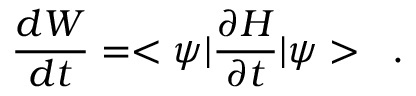<formula> <loc_0><loc_0><loc_500><loc_500>\frac { d W } { d t } = < \psi | \frac { \partial H } { \partial t } | \psi > \, .</formula> 